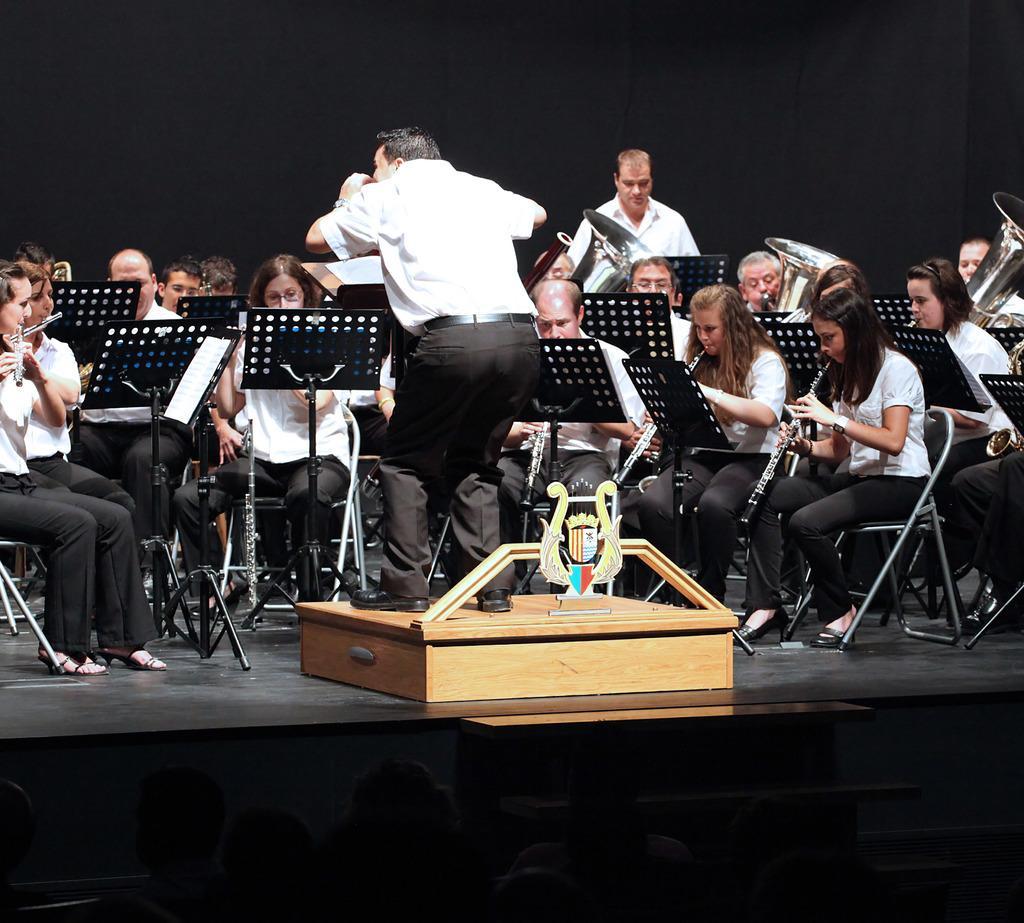Describe this image in one or two sentences. There is a person standing on a wooden box wearing a white shirt and trousers. People are seated on the chairs wearing same dress and playing musical instruments. There are papers and its stands. The background is black in color. 